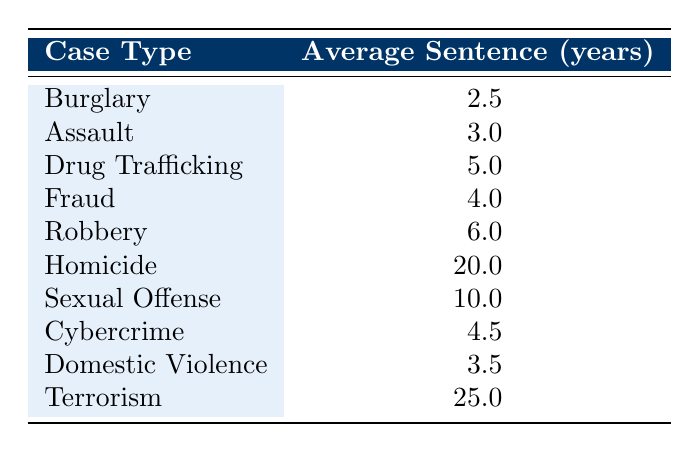What is the average sentence length for Cybercrime? The table lists Cybercrime with an average sentence length of 4.5 years. Thus, this value is retrieved directly from the table without further calculations.
Answer: 4.5 Which case type has the longest average sentence length? The table reveals that Terrorism has the highest average sentence length of 25.0 years. This is determined by comparing the average sentence lengths of all case types listed.
Answer: 25.0 Is the average sentence length for Drug Trafficking greater than the average for Fraud? Drug Trafficking has an average sentence length of 5.0 years, and Fraud has 4.0 years. Since 5.0 is greater than 4.0, the answer to this question is yes.
Answer: Yes What is the total average sentence length of Homicide and Sexual Offense? The average sentence length for Homicide is 20.0 years and for Sexual Offense is 10.0 years. To find the total, we add these two values: 20.0 + 10.0 = 30.0.
Answer: 30.0 How many case types have an average sentence length of less than 5 years? From the table, we identify the case types with average sentence lengths of less than 5 years: Burglary (2.5), Assault (3.0), Domestic Violence (3.5) — totaling three.
Answer: 3 What is the difference between the average sentence lengths of Robbery and Assault? Robbery has an average sentence length of 6.0 years and Assault has 3.0 years. The difference is calculated by subtracting the average of Assault from that of Robbery: 6.0 - 3.0 = 3.0.
Answer: 3.0 Is the average sentence length for Domestic Violence greater than that of Burglary? Domestic Violence has an average sentence length of 3.5 years, while Burglary has 2.5 years. Since 3.5 is greater than 2.5, the answer is yes.
Answer: Yes Which case types have an average sentence length over 10 years? Looking at the table, the case types with over 10 years are Homicide (20.0) and Terrorism (25.0). This is a straightforward listing of case types according to their average sentence lengths.
Answer: Homicide, Terrorism What is the average of the average sentence lengths for all case types? To calculate the average of the average sentence lengths, we sum all the given lengths: (2.5 + 3.0 + 5.0 + 4.0 + 6.0 + 20.0 + 10.0 + 4.5 + 3.5 + 25.0 = 73.5) and divide by the number of case types (10). Thus, 73.5 / 10 = 7.35.
Answer: 7.35 